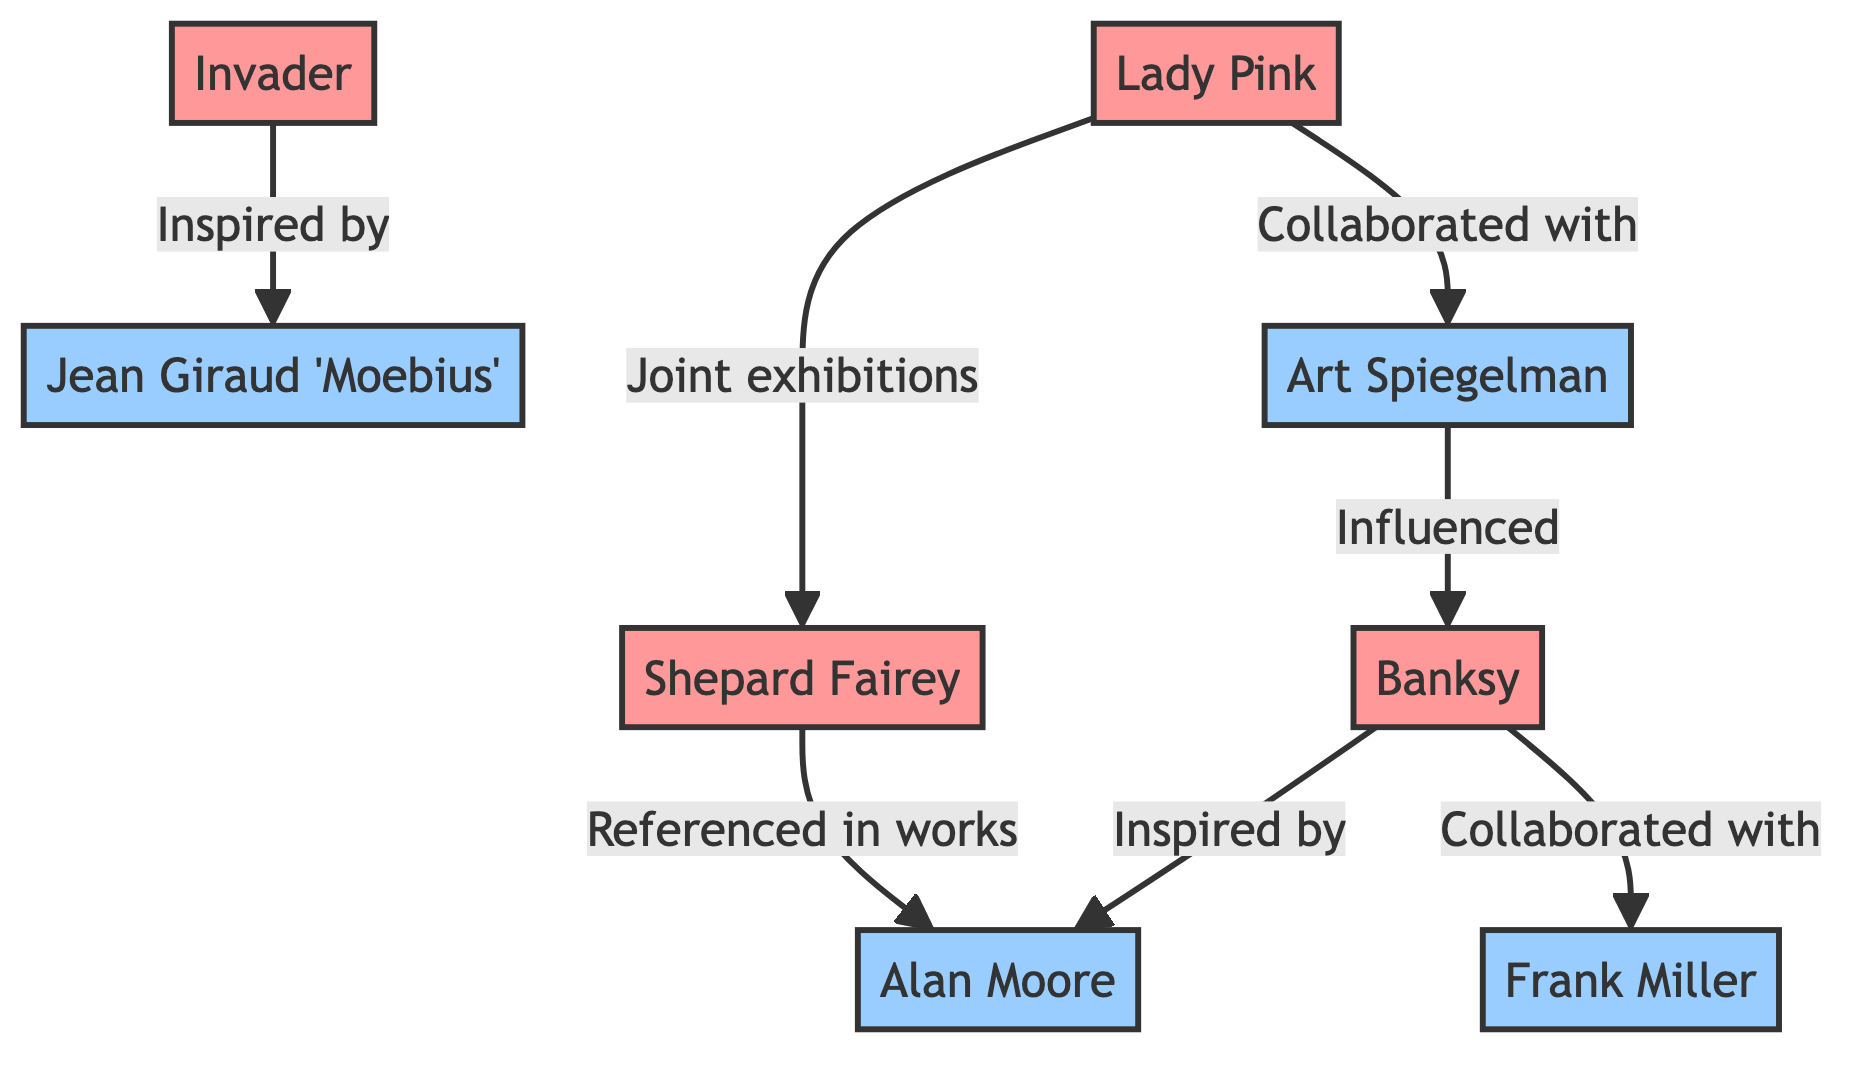What is the total number of nodes in the diagram? The nodes in the diagram include Banksy, Shepard Fairey, Invader, Art Spiegelman, Frank Miller, Alan Moore, Lady Pink, and Jean Giraud 'Moebius'. Counting these gives a total of 8 nodes.
Answer: 8 Who is inspired by Alan Moore? The only directed edge going from the node representing Banksy to the node representing Alan Moore indicates that Banksy is inspired by Alan Moore.
Answer: Banksy How many connections are attributed to Lady Pink? Lady Pink is connected to Shepard Fairey and Art Spiegelman through the edges representing "Joint exhibitions" and "Collaborated with," which sums up to 2 connections.
Answer: 2 Which artist has a collaboration with Frank Miller? The directed edge indicates that Banksy has a collaboration with Frank Miller. Following the edge from Banksy, we see the label "Collaborated with" pointing to Frank Miller.
Answer: Frank Miller Which street artist is influenced by Art Spiegelman? The edge going from Art Spiegelman to Banksy indicates that Banksy is influenced by Art Spiegelman. The relationship labeled as "Influenced" shows this connection.
Answer: Banksy What is the relationship between Invader and Jean Giraud 'Moebius'? The diagram shows that Invader is inspired by Jean Giraud 'Moebius' as indicated by the directed edge labeled "Inspired by."
Answer: Inspired by Which comic artist is referenced in Shepard Fairey's works? The directed edge from Shepard Fairey to Alan Moore indicates that Alan Moore is referenced in Shepard Fairey's works.
Answer: Alan Moore How many street artists are connected to comic artists? The connections in the diagram show that Banksy, Shepard Fairey, and Lady Pink, each linked to comic artists Alan Moore, Frank Miller, and Art Spiegelman respectively. There are 4 connections between the street artists and comic artists in total.
Answer: 4 Which artist has the most connections in the diagram? Analyzing the nodes, Banksy connects to Alan Moore (Inspired by), Frank Miller (Collaborated with), and is also influenced by Art Spiegelman. Therefore, Banksy has 3 connections, making it the artist with the most connections in the diagram.
Answer: Banksy 